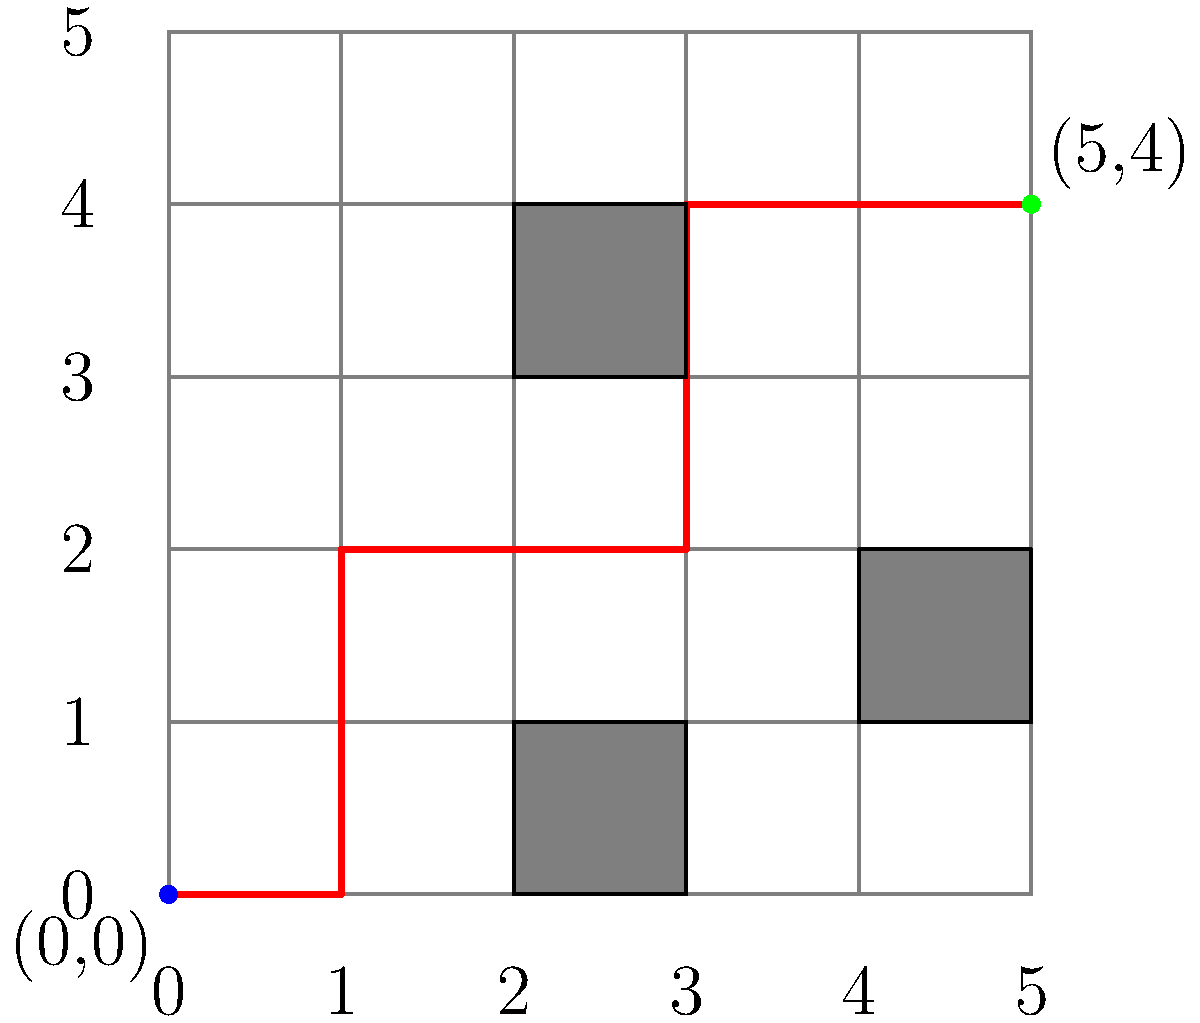In this Game Boy Advance-inspired level, you need to navigate from the blue starting point at $(0,0)$ to the green goal at $(5,4)$. The gray squares represent obstacles that you cannot pass through. Using the grid coordinate system, what is the minimum number of steps required to reach the goal, moving only horizontally or vertically? To solve this problem, we'll follow these steps:

1. Analyze the grid: The grid is $6 \times 5$, with the start at $(0,0)$ and the goal at $(5,4)$.

2. Identify obstacles: There are three obstacles at $(2,0)$, $(2,3)$, and $(4,1)$.

3. Find the shortest path:
   a. Move right: $(0,0) \to (1,0)$ (1 step)
   b. Move up: $(1,0) \to (1,2)$ (2 steps)
   c. Move right: $(1,2) \to (3,2)$ (2 steps)
   d. Move up: $(3,2) \to (3,4)$ (2 steps)
   e. Move right: $(3,4) \to (5,4)$ (2 steps)

4. Count total steps: $1 + 2 + 2 + 2 + 2 = 9$ steps

The red line in the diagram shows this optimal path.

Note: This path avoids all obstacles and uses only horizontal and vertical movements, which is typical for classic Game Boy Advance games like the Shantae series.
Answer: 9 steps 